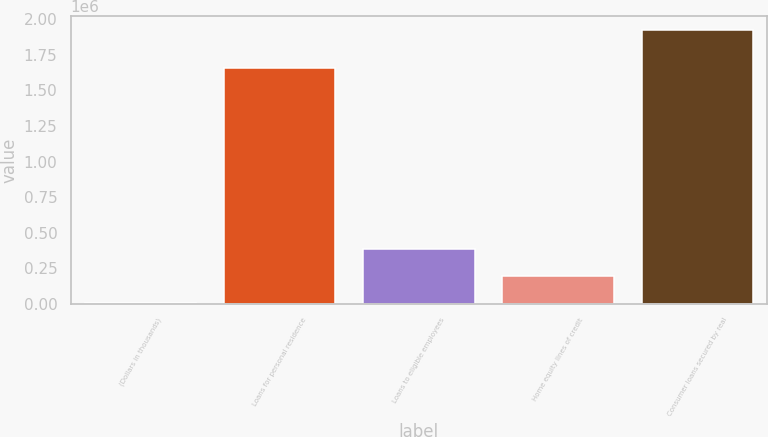Convert chart to OTSL. <chart><loc_0><loc_0><loc_500><loc_500><bar_chart><fcel>(Dollars in thousands)<fcel>Loans for personal residence<fcel>Loans to eligible employees<fcel>Home equity lines of credit<fcel>Consumer loans secured by real<nl><fcel>2016<fcel>1.65535e+06<fcel>387006<fcel>194511<fcel>1.92697e+06<nl></chart> 